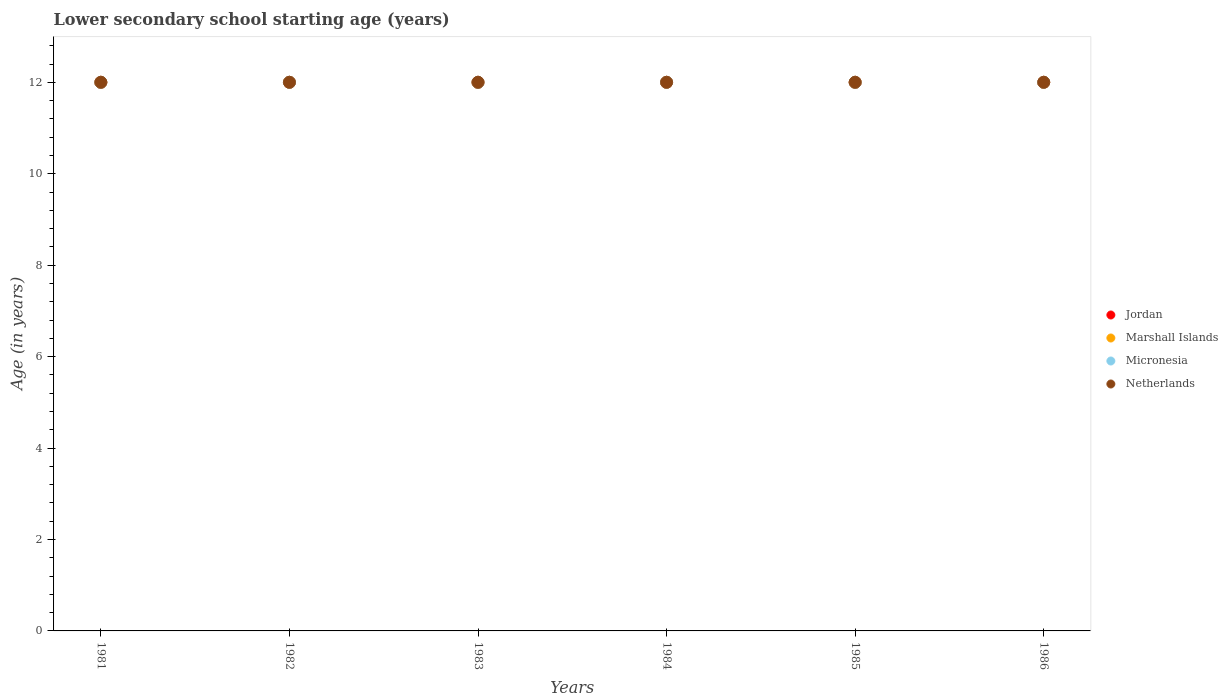Across all years, what is the maximum lower secondary school starting age of children in Micronesia?
Provide a short and direct response. 12. Across all years, what is the minimum lower secondary school starting age of children in Jordan?
Ensure brevity in your answer.  12. What is the total lower secondary school starting age of children in Micronesia in the graph?
Ensure brevity in your answer.  72. What is the difference between the lower secondary school starting age of children in Marshall Islands in 1981 and that in 1986?
Ensure brevity in your answer.  0. What is the difference between the lower secondary school starting age of children in Netherlands in 1984 and the lower secondary school starting age of children in Marshall Islands in 1981?
Keep it short and to the point. 0. In the year 1981, what is the difference between the lower secondary school starting age of children in Marshall Islands and lower secondary school starting age of children in Jordan?
Provide a succinct answer. 0. In how many years, is the lower secondary school starting age of children in Jordan greater than 2.4 years?
Offer a very short reply. 6. What is the ratio of the lower secondary school starting age of children in Micronesia in 1985 to that in 1986?
Ensure brevity in your answer.  1. Is the lower secondary school starting age of children in Netherlands in 1983 less than that in 1984?
Your answer should be compact. No. What is the difference between the highest and the second highest lower secondary school starting age of children in Micronesia?
Make the answer very short. 0. In how many years, is the lower secondary school starting age of children in Netherlands greater than the average lower secondary school starting age of children in Netherlands taken over all years?
Offer a terse response. 0. Is it the case that in every year, the sum of the lower secondary school starting age of children in Marshall Islands and lower secondary school starting age of children in Micronesia  is greater than the sum of lower secondary school starting age of children in Jordan and lower secondary school starting age of children in Netherlands?
Keep it short and to the point. No. Is the lower secondary school starting age of children in Netherlands strictly greater than the lower secondary school starting age of children in Micronesia over the years?
Keep it short and to the point. No. How many years are there in the graph?
Provide a succinct answer. 6. Are the values on the major ticks of Y-axis written in scientific E-notation?
Ensure brevity in your answer.  No. Does the graph contain any zero values?
Keep it short and to the point. No. What is the title of the graph?
Make the answer very short. Lower secondary school starting age (years). Does "Russian Federation" appear as one of the legend labels in the graph?
Make the answer very short. No. What is the label or title of the Y-axis?
Make the answer very short. Age (in years). What is the Age (in years) of Jordan in 1981?
Provide a short and direct response. 12. What is the Age (in years) in Marshall Islands in 1981?
Ensure brevity in your answer.  12. What is the Age (in years) of Micronesia in 1981?
Offer a very short reply. 12. What is the Age (in years) in Netherlands in 1981?
Make the answer very short. 12. What is the Age (in years) of Marshall Islands in 1982?
Offer a very short reply. 12. What is the Age (in years) of Netherlands in 1982?
Give a very brief answer. 12. What is the Age (in years) in Jordan in 1983?
Provide a short and direct response. 12. What is the Age (in years) in Marshall Islands in 1983?
Give a very brief answer. 12. What is the Age (in years) in Netherlands in 1983?
Give a very brief answer. 12. What is the Age (in years) in Jordan in 1984?
Offer a terse response. 12. What is the Age (in years) in Marshall Islands in 1984?
Ensure brevity in your answer.  12. What is the Age (in years) in Micronesia in 1984?
Your answer should be compact. 12. What is the Age (in years) of Netherlands in 1985?
Provide a succinct answer. 12. What is the Age (in years) in Micronesia in 1986?
Offer a very short reply. 12. What is the Age (in years) in Netherlands in 1986?
Offer a very short reply. 12. Across all years, what is the maximum Age (in years) of Jordan?
Your answer should be compact. 12. Across all years, what is the maximum Age (in years) in Marshall Islands?
Ensure brevity in your answer.  12. Across all years, what is the maximum Age (in years) of Micronesia?
Your answer should be compact. 12. Across all years, what is the maximum Age (in years) in Netherlands?
Offer a very short reply. 12. Across all years, what is the minimum Age (in years) of Marshall Islands?
Your response must be concise. 12. Across all years, what is the minimum Age (in years) of Netherlands?
Give a very brief answer. 12. What is the total Age (in years) in Jordan in the graph?
Provide a short and direct response. 72. What is the total Age (in years) in Marshall Islands in the graph?
Make the answer very short. 72. What is the total Age (in years) in Micronesia in the graph?
Give a very brief answer. 72. What is the total Age (in years) of Netherlands in the graph?
Provide a succinct answer. 72. What is the difference between the Age (in years) in Micronesia in 1981 and that in 1982?
Provide a short and direct response. 0. What is the difference between the Age (in years) of Jordan in 1981 and that in 1983?
Give a very brief answer. 0. What is the difference between the Age (in years) in Micronesia in 1981 and that in 1983?
Make the answer very short. 0. What is the difference between the Age (in years) of Netherlands in 1981 and that in 1983?
Your answer should be very brief. 0. What is the difference between the Age (in years) in Micronesia in 1981 and that in 1984?
Keep it short and to the point. 0. What is the difference between the Age (in years) in Jordan in 1981 and that in 1985?
Provide a short and direct response. 0. What is the difference between the Age (in years) in Marshall Islands in 1981 and that in 1985?
Provide a short and direct response. 0. What is the difference between the Age (in years) in Netherlands in 1981 and that in 1985?
Make the answer very short. 0. What is the difference between the Age (in years) of Marshall Islands in 1981 and that in 1986?
Your answer should be compact. 0. What is the difference between the Age (in years) of Netherlands in 1981 and that in 1986?
Provide a short and direct response. 0. What is the difference between the Age (in years) of Micronesia in 1982 and that in 1983?
Ensure brevity in your answer.  0. What is the difference between the Age (in years) in Netherlands in 1982 and that in 1983?
Provide a succinct answer. 0. What is the difference between the Age (in years) in Jordan in 1982 and that in 1984?
Provide a short and direct response. 0. What is the difference between the Age (in years) of Marshall Islands in 1982 and that in 1984?
Provide a short and direct response. 0. What is the difference between the Age (in years) in Netherlands in 1982 and that in 1984?
Offer a very short reply. 0. What is the difference between the Age (in years) of Jordan in 1982 and that in 1985?
Make the answer very short. 0. What is the difference between the Age (in years) of Marshall Islands in 1982 and that in 1985?
Provide a succinct answer. 0. What is the difference between the Age (in years) in Micronesia in 1982 and that in 1985?
Provide a succinct answer. 0. What is the difference between the Age (in years) in Marshall Islands in 1982 and that in 1986?
Provide a short and direct response. 0. What is the difference between the Age (in years) in Netherlands in 1982 and that in 1986?
Make the answer very short. 0. What is the difference between the Age (in years) of Marshall Islands in 1983 and that in 1984?
Offer a terse response. 0. What is the difference between the Age (in years) in Marshall Islands in 1983 and that in 1985?
Offer a terse response. 0. What is the difference between the Age (in years) in Netherlands in 1983 and that in 1986?
Provide a short and direct response. 0. What is the difference between the Age (in years) in Jordan in 1984 and that in 1985?
Offer a terse response. 0. What is the difference between the Age (in years) of Marshall Islands in 1984 and that in 1985?
Keep it short and to the point. 0. What is the difference between the Age (in years) of Micronesia in 1984 and that in 1985?
Ensure brevity in your answer.  0. What is the difference between the Age (in years) in Jordan in 1984 and that in 1986?
Make the answer very short. 0. What is the difference between the Age (in years) in Netherlands in 1984 and that in 1986?
Your response must be concise. 0. What is the difference between the Age (in years) of Micronesia in 1985 and that in 1986?
Provide a succinct answer. 0. What is the difference between the Age (in years) of Netherlands in 1985 and that in 1986?
Provide a succinct answer. 0. What is the difference between the Age (in years) in Jordan in 1981 and the Age (in years) in Marshall Islands in 1982?
Provide a short and direct response. 0. What is the difference between the Age (in years) in Jordan in 1981 and the Age (in years) in Netherlands in 1982?
Your response must be concise. 0. What is the difference between the Age (in years) in Jordan in 1981 and the Age (in years) in Micronesia in 1983?
Make the answer very short. 0. What is the difference between the Age (in years) in Jordan in 1981 and the Age (in years) in Netherlands in 1983?
Your answer should be compact. 0. What is the difference between the Age (in years) in Marshall Islands in 1981 and the Age (in years) in Micronesia in 1983?
Provide a succinct answer. 0. What is the difference between the Age (in years) of Micronesia in 1981 and the Age (in years) of Netherlands in 1983?
Offer a terse response. 0. What is the difference between the Age (in years) of Jordan in 1981 and the Age (in years) of Marshall Islands in 1984?
Provide a short and direct response. 0. What is the difference between the Age (in years) of Marshall Islands in 1981 and the Age (in years) of Micronesia in 1984?
Offer a terse response. 0. What is the difference between the Age (in years) in Marshall Islands in 1981 and the Age (in years) in Netherlands in 1984?
Provide a short and direct response. 0. What is the difference between the Age (in years) in Jordan in 1981 and the Age (in years) in Marshall Islands in 1985?
Your answer should be very brief. 0. What is the difference between the Age (in years) of Micronesia in 1981 and the Age (in years) of Netherlands in 1985?
Offer a terse response. 0. What is the difference between the Age (in years) of Jordan in 1981 and the Age (in years) of Marshall Islands in 1986?
Provide a short and direct response. 0. What is the difference between the Age (in years) in Jordan in 1981 and the Age (in years) in Micronesia in 1986?
Provide a short and direct response. 0. What is the difference between the Age (in years) in Marshall Islands in 1981 and the Age (in years) in Netherlands in 1986?
Your response must be concise. 0. What is the difference between the Age (in years) in Jordan in 1982 and the Age (in years) in Netherlands in 1983?
Make the answer very short. 0. What is the difference between the Age (in years) of Micronesia in 1982 and the Age (in years) of Netherlands in 1983?
Your answer should be compact. 0. What is the difference between the Age (in years) of Jordan in 1982 and the Age (in years) of Marshall Islands in 1984?
Keep it short and to the point. 0. What is the difference between the Age (in years) of Jordan in 1982 and the Age (in years) of Micronesia in 1984?
Your response must be concise. 0. What is the difference between the Age (in years) of Jordan in 1982 and the Age (in years) of Netherlands in 1984?
Offer a very short reply. 0. What is the difference between the Age (in years) in Marshall Islands in 1982 and the Age (in years) in Micronesia in 1984?
Give a very brief answer. 0. What is the difference between the Age (in years) in Micronesia in 1982 and the Age (in years) in Netherlands in 1984?
Offer a very short reply. 0. What is the difference between the Age (in years) of Jordan in 1982 and the Age (in years) of Micronesia in 1985?
Your answer should be compact. 0. What is the difference between the Age (in years) in Jordan in 1982 and the Age (in years) in Netherlands in 1985?
Provide a short and direct response. 0. What is the difference between the Age (in years) in Marshall Islands in 1982 and the Age (in years) in Micronesia in 1985?
Your response must be concise. 0. What is the difference between the Age (in years) of Micronesia in 1982 and the Age (in years) of Netherlands in 1985?
Provide a short and direct response. 0. What is the difference between the Age (in years) in Micronesia in 1982 and the Age (in years) in Netherlands in 1986?
Your response must be concise. 0. What is the difference between the Age (in years) in Jordan in 1983 and the Age (in years) in Netherlands in 1984?
Offer a terse response. 0. What is the difference between the Age (in years) of Marshall Islands in 1983 and the Age (in years) of Micronesia in 1984?
Offer a very short reply. 0. What is the difference between the Age (in years) of Jordan in 1983 and the Age (in years) of Marshall Islands in 1985?
Offer a terse response. 0. What is the difference between the Age (in years) of Jordan in 1983 and the Age (in years) of Marshall Islands in 1986?
Your answer should be compact. 0. What is the difference between the Age (in years) in Jordan in 1983 and the Age (in years) in Micronesia in 1986?
Offer a terse response. 0. What is the difference between the Age (in years) of Jordan in 1984 and the Age (in years) of Netherlands in 1985?
Ensure brevity in your answer.  0. What is the difference between the Age (in years) of Marshall Islands in 1984 and the Age (in years) of Micronesia in 1985?
Your answer should be compact. 0. What is the difference between the Age (in years) of Jordan in 1984 and the Age (in years) of Marshall Islands in 1986?
Your answer should be compact. 0. What is the difference between the Age (in years) of Jordan in 1984 and the Age (in years) of Micronesia in 1986?
Make the answer very short. 0. What is the difference between the Age (in years) of Jordan in 1985 and the Age (in years) of Micronesia in 1986?
Offer a terse response. 0. What is the difference between the Age (in years) of Marshall Islands in 1985 and the Age (in years) of Netherlands in 1986?
Provide a short and direct response. 0. What is the average Age (in years) of Jordan per year?
Ensure brevity in your answer.  12. What is the average Age (in years) of Micronesia per year?
Provide a succinct answer. 12. In the year 1981, what is the difference between the Age (in years) of Jordan and Age (in years) of Micronesia?
Your answer should be very brief. 0. In the year 1981, what is the difference between the Age (in years) in Micronesia and Age (in years) in Netherlands?
Ensure brevity in your answer.  0. In the year 1982, what is the difference between the Age (in years) of Jordan and Age (in years) of Micronesia?
Offer a very short reply. 0. In the year 1982, what is the difference between the Age (in years) of Jordan and Age (in years) of Netherlands?
Keep it short and to the point. 0. In the year 1982, what is the difference between the Age (in years) of Marshall Islands and Age (in years) of Netherlands?
Provide a succinct answer. 0. In the year 1983, what is the difference between the Age (in years) of Jordan and Age (in years) of Marshall Islands?
Offer a terse response. 0. In the year 1983, what is the difference between the Age (in years) of Jordan and Age (in years) of Micronesia?
Offer a very short reply. 0. In the year 1983, what is the difference between the Age (in years) in Marshall Islands and Age (in years) in Micronesia?
Provide a succinct answer. 0. In the year 1983, what is the difference between the Age (in years) of Micronesia and Age (in years) of Netherlands?
Ensure brevity in your answer.  0. In the year 1984, what is the difference between the Age (in years) of Jordan and Age (in years) of Micronesia?
Ensure brevity in your answer.  0. In the year 1984, what is the difference between the Age (in years) of Jordan and Age (in years) of Netherlands?
Offer a terse response. 0. In the year 1984, what is the difference between the Age (in years) of Marshall Islands and Age (in years) of Micronesia?
Provide a succinct answer. 0. In the year 1984, what is the difference between the Age (in years) in Marshall Islands and Age (in years) in Netherlands?
Provide a short and direct response. 0. In the year 1985, what is the difference between the Age (in years) of Jordan and Age (in years) of Netherlands?
Your answer should be very brief. 0. In the year 1985, what is the difference between the Age (in years) in Marshall Islands and Age (in years) in Micronesia?
Keep it short and to the point. 0. In the year 1985, what is the difference between the Age (in years) in Marshall Islands and Age (in years) in Netherlands?
Offer a very short reply. 0. In the year 1985, what is the difference between the Age (in years) of Micronesia and Age (in years) of Netherlands?
Your response must be concise. 0. In the year 1986, what is the difference between the Age (in years) in Marshall Islands and Age (in years) in Netherlands?
Your answer should be compact. 0. In the year 1986, what is the difference between the Age (in years) of Micronesia and Age (in years) of Netherlands?
Make the answer very short. 0. What is the ratio of the Age (in years) of Marshall Islands in 1981 to that in 1982?
Provide a short and direct response. 1. What is the ratio of the Age (in years) of Netherlands in 1981 to that in 1982?
Your response must be concise. 1. What is the ratio of the Age (in years) in Jordan in 1981 to that in 1983?
Offer a terse response. 1. What is the ratio of the Age (in years) of Micronesia in 1981 to that in 1983?
Ensure brevity in your answer.  1. What is the ratio of the Age (in years) of Jordan in 1981 to that in 1984?
Give a very brief answer. 1. What is the ratio of the Age (in years) in Jordan in 1981 to that in 1985?
Offer a terse response. 1. What is the ratio of the Age (in years) of Netherlands in 1981 to that in 1985?
Provide a short and direct response. 1. What is the ratio of the Age (in years) in Jordan in 1981 to that in 1986?
Provide a short and direct response. 1. What is the ratio of the Age (in years) of Netherlands in 1981 to that in 1986?
Your answer should be compact. 1. What is the ratio of the Age (in years) of Marshall Islands in 1982 to that in 1983?
Your answer should be compact. 1. What is the ratio of the Age (in years) in Micronesia in 1982 to that in 1983?
Keep it short and to the point. 1. What is the ratio of the Age (in years) in Micronesia in 1982 to that in 1984?
Provide a short and direct response. 1. What is the ratio of the Age (in years) of Netherlands in 1982 to that in 1984?
Make the answer very short. 1. What is the ratio of the Age (in years) of Jordan in 1982 to that in 1985?
Provide a succinct answer. 1. What is the ratio of the Age (in years) in Marshall Islands in 1982 to that in 1985?
Provide a succinct answer. 1. What is the ratio of the Age (in years) of Micronesia in 1982 to that in 1985?
Make the answer very short. 1. What is the ratio of the Age (in years) in Netherlands in 1982 to that in 1985?
Your answer should be very brief. 1. What is the ratio of the Age (in years) of Jordan in 1983 to that in 1984?
Keep it short and to the point. 1. What is the ratio of the Age (in years) of Micronesia in 1983 to that in 1984?
Give a very brief answer. 1. What is the ratio of the Age (in years) in Jordan in 1983 to that in 1985?
Your answer should be very brief. 1. What is the ratio of the Age (in years) in Marshall Islands in 1983 to that in 1985?
Provide a succinct answer. 1. What is the ratio of the Age (in years) of Jordan in 1983 to that in 1986?
Offer a terse response. 1. What is the ratio of the Age (in years) of Netherlands in 1983 to that in 1986?
Your response must be concise. 1. What is the ratio of the Age (in years) in Marshall Islands in 1984 to that in 1985?
Provide a succinct answer. 1. What is the ratio of the Age (in years) in Netherlands in 1984 to that in 1985?
Offer a terse response. 1. What is the ratio of the Age (in years) in Marshall Islands in 1984 to that in 1986?
Your answer should be very brief. 1. What is the ratio of the Age (in years) of Micronesia in 1984 to that in 1986?
Make the answer very short. 1. What is the ratio of the Age (in years) in Netherlands in 1984 to that in 1986?
Offer a terse response. 1. What is the difference between the highest and the second highest Age (in years) in Marshall Islands?
Your response must be concise. 0. What is the difference between the highest and the second highest Age (in years) in Micronesia?
Provide a succinct answer. 0. What is the difference between the highest and the second highest Age (in years) in Netherlands?
Provide a succinct answer. 0. What is the difference between the highest and the lowest Age (in years) of Jordan?
Your answer should be very brief. 0. 